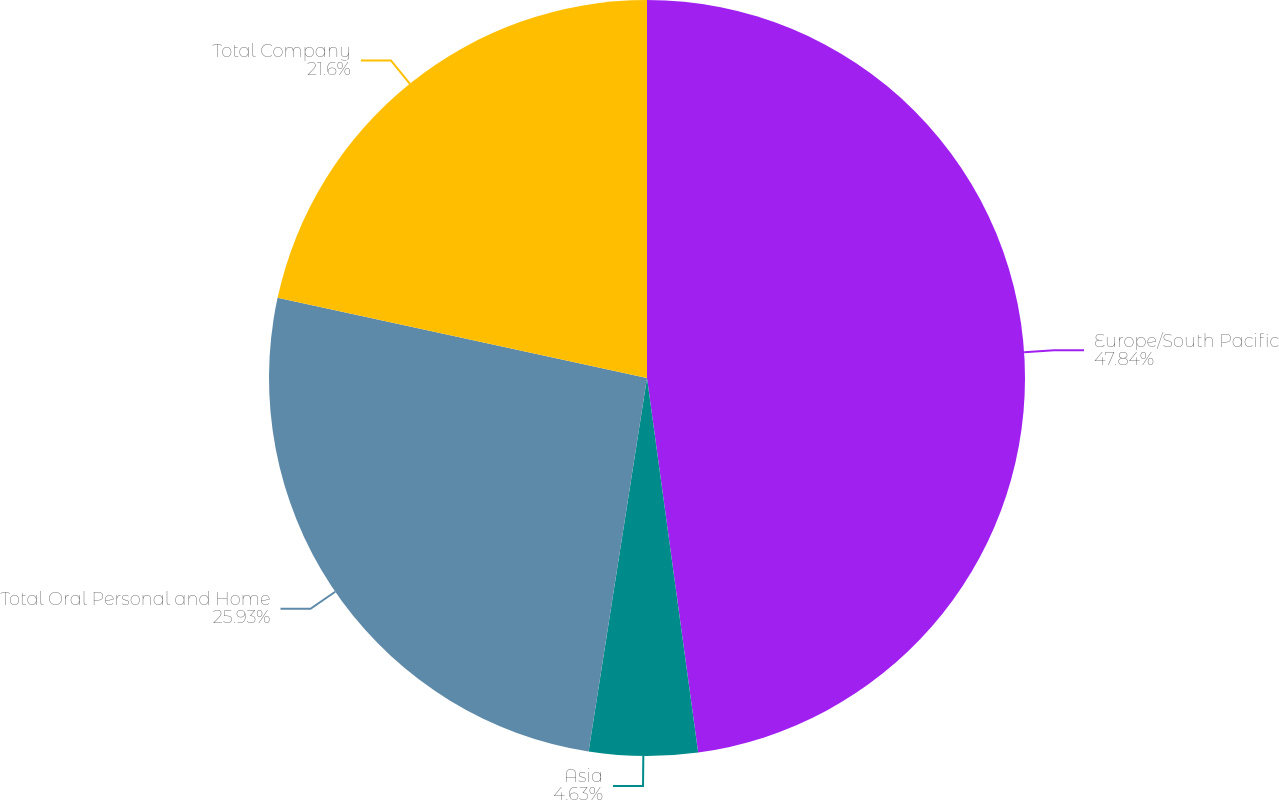<chart> <loc_0><loc_0><loc_500><loc_500><pie_chart><fcel>Europe/South Pacific<fcel>Asia<fcel>Total Oral Personal and Home<fcel>Total Company<nl><fcel>47.84%<fcel>4.63%<fcel>25.93%<fcel>21.6%<nl></chart> 